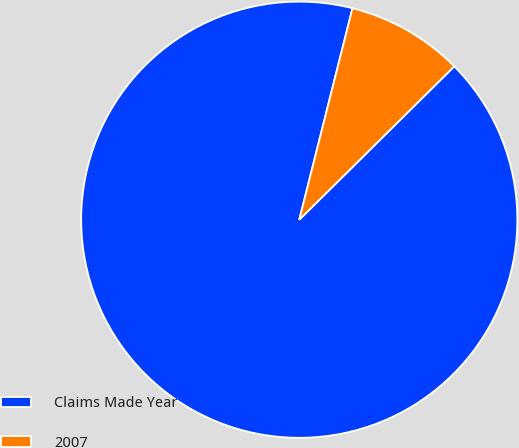Convert chart. <chart><loc_0><loc_0><loc_500><loc_500><pie_chart><fcel>Claims Made Year<fcel>2007<nl><fcel>91.34%<fcel>8.66%<nl></chart> 